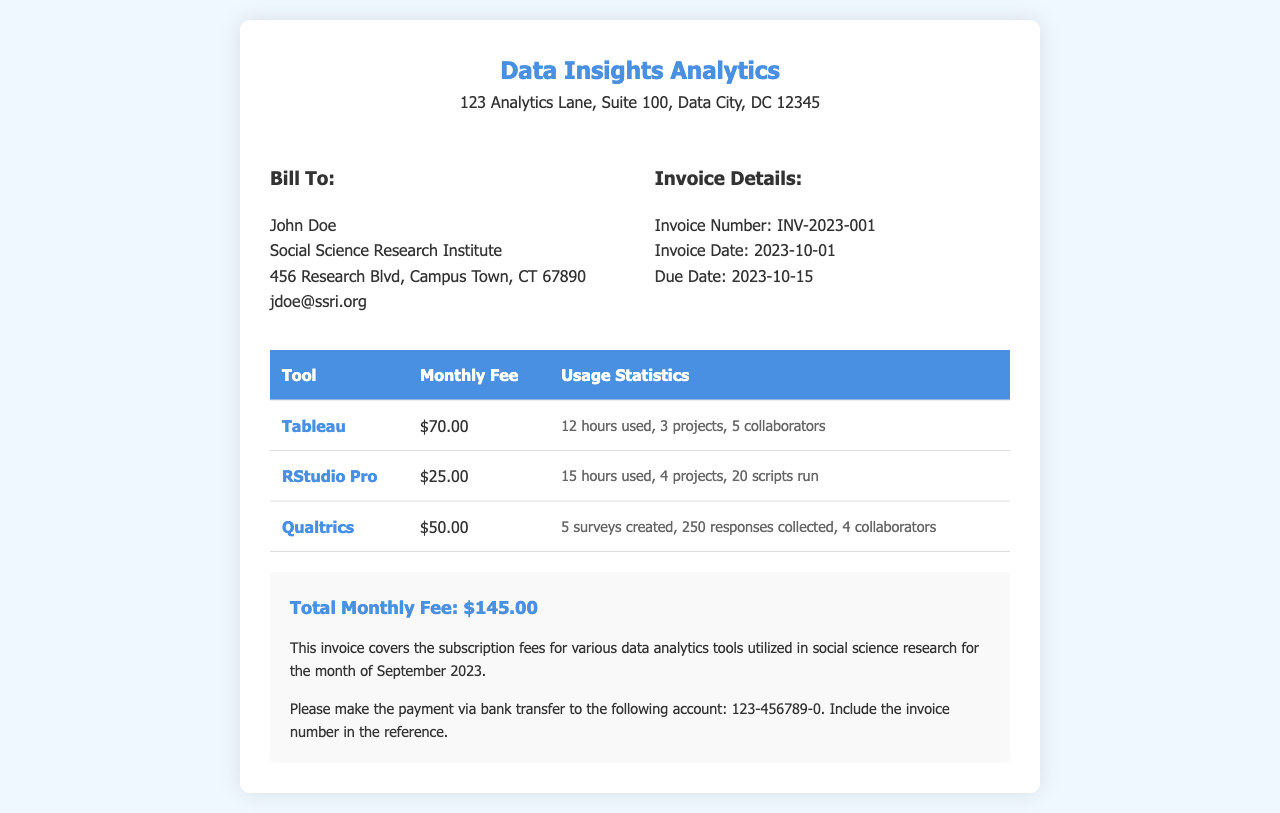What is the invoice number? The invoice number is a unique identifier for this invoice, which is listed in the document.
Answer: INV-2023-001 What is the total monthly fee? The total monthly fee is calculated by adding all individual tool fees listed in the invoice.
Answer: $145.00 How many hours were used on Tableau? The document provides usage statistics for Tableau, including the hours used.
Answer: 12 hours What is the due date of the invoice? The due date is specified in the invoice details section, indicating when payment is required.
Answer: 2023-10-15 Which tool had the highest monthly fee? By comparing the monthly fees listed for each tool, we can identify the one with the highest price.
Answer: Tableau How many surveys were created using Qualtrics? The usage statistics for Qualtrics detail how many surveys were created during the month.
Answer: 5 surveys Who is the billing contact mentioned in the invoice? The bill to section contains the name of the individual responsible for the payment.
Answer: John Doe What type of payment is requested? The payment instructions specify how payments should be made in the invoice.
Answer: Bank transfer What was the total amount due for September 2023? The total amount due for the service period can be found in the summary section of the document.
Answer: $145.00 